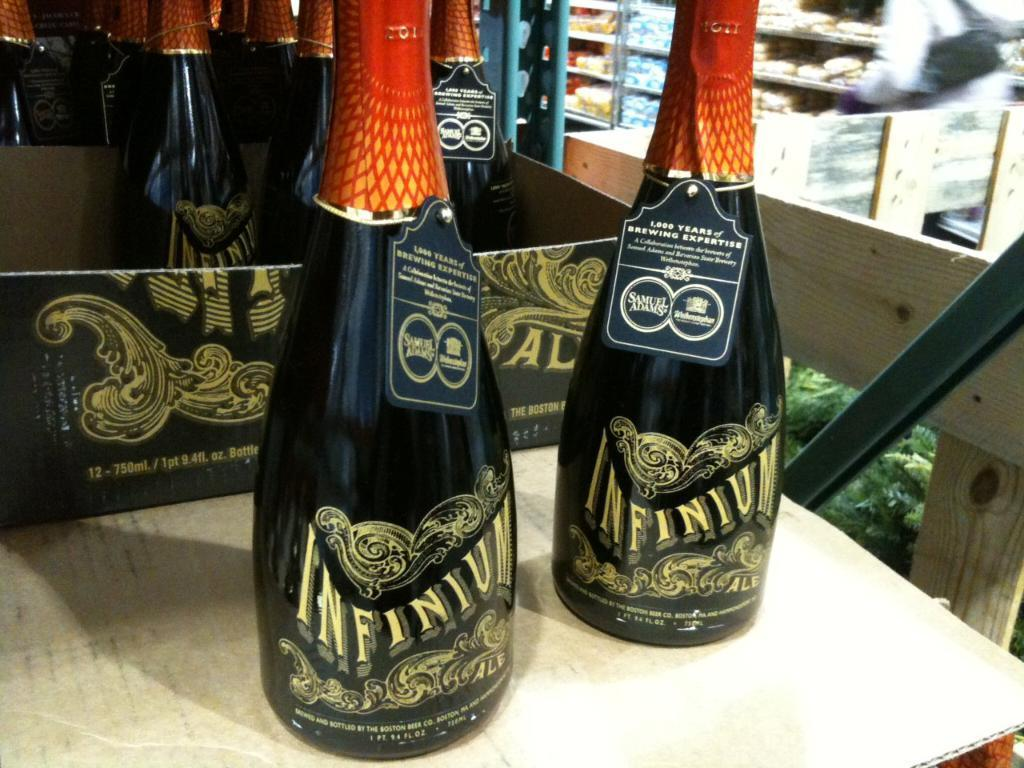<image>
Provide a brief description of the given image. Black bottles of Infinium beer by Samuel Adams 